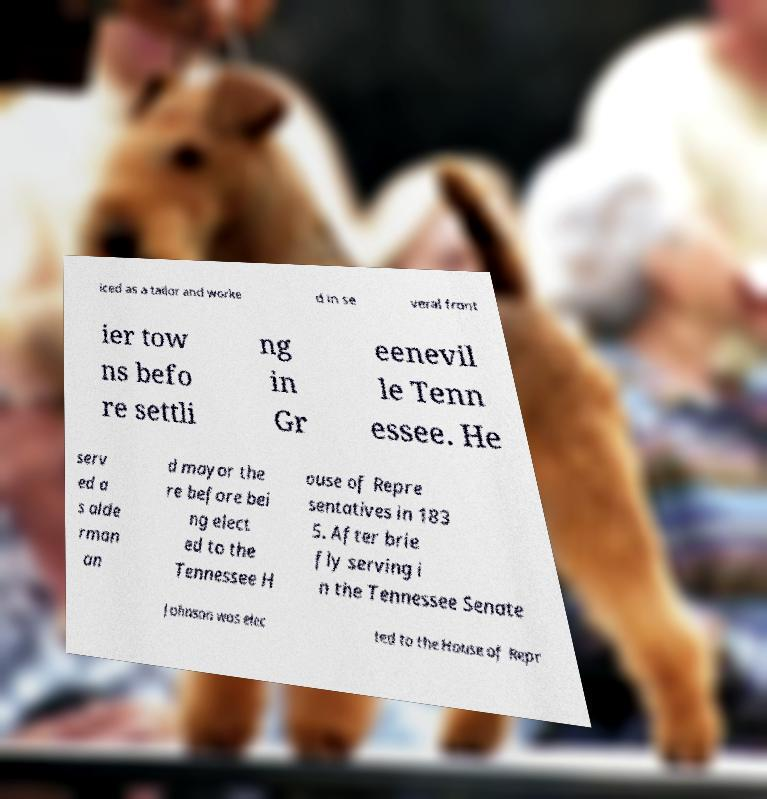There's text embedded in this image that I need extracted. Can you transcribe it verbatim? iced as a tailor and worke d in se veral front ier tow ns befo re settli ng in Gr eenevil le Tenn essee. He serv ed a s alde rman an d mayor the re before bei ng elect ed to the Tennessee H ouse of Repre sentatives in 183 5. After brie fly serving i n the Tennessee Senate Johnson was elec ted to the House of Repr 